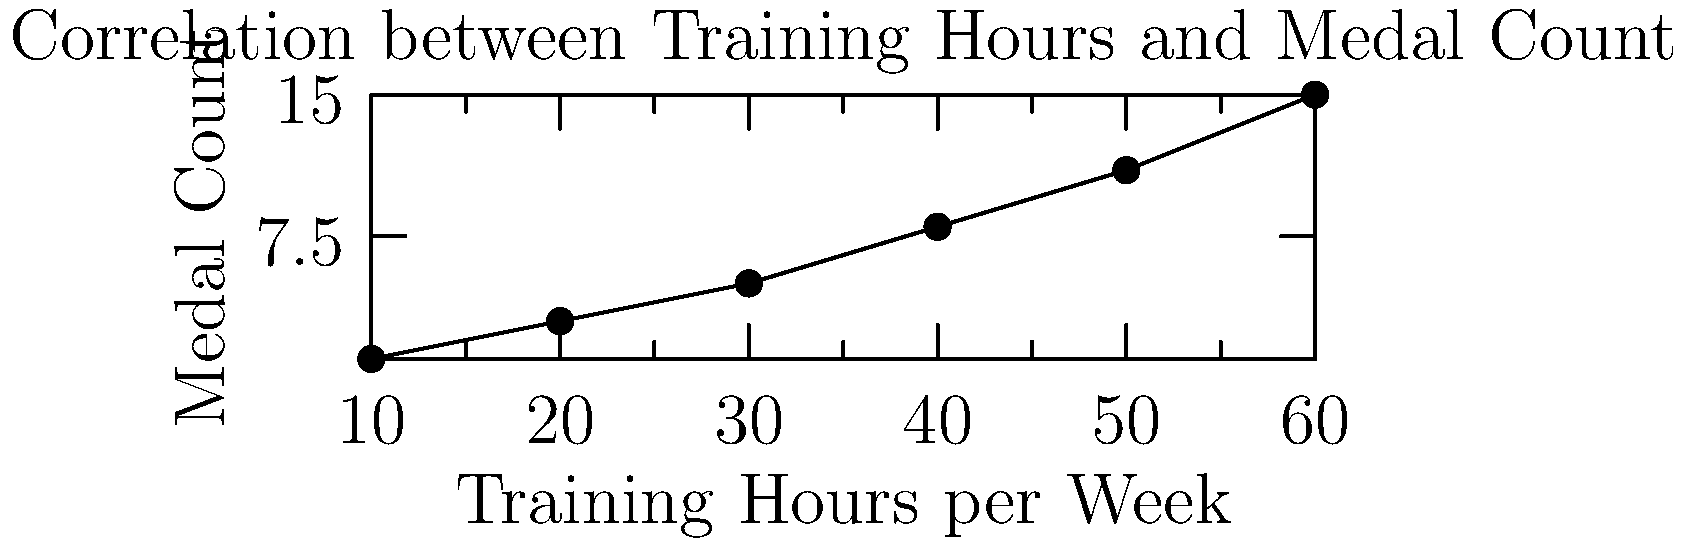Based on the graph showing the correlation between weekly training hours and medal counts in Olympic gymnastics, what is the approximate increase in medal count for every 10-hour increase in weekly training? To determine the approximate increase in medal count for every 10-hour increase in weekly training, we need to analyze the trend in the graph. Let's follow these steps:

1. Identify two points on the graph that are 10 hours apart:
   - At 20 hours: approximately 3 medals
   - At 30 hours: approximately 5 medals

2. Calculate the difference in medal count:
   $5 - 3 = 2$ medals

3. Verify this pattern at other intervals:
   - 30 to 40 hours: from 5 to 8 medals (increase of 3)
   - 40 to 50 hours: from 8 to 11 medals (increase of 3)
   - 50 to 60 hours: from 11 to 15 medals (increase of 4)

4. Observe that the increase is not perfectly consistent but averages around 2-3 medals per 10-hour increase.

5. Consider the overall trend:
   The relationship appears to be slightly non-linear, with larger increases at higher training hours.

6. Conclude:
   On average, the medal count increases by approximately 2-3 for every 10-hour increase in weekly training.
Answer: 2-3 medals 